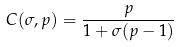Convert formula to latex. <formula><loc_0><loc_0><loc_500><loc_500>C ( \sigma , p ) = \frac { p } { 1 + \sigma ( p - 1 ) }</formula> 